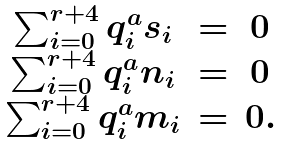<formula> <loc_0><loc_0><loc_500><loc_500>\begin{array} { c c c } \sum _ { i = 0 } ^ { r + 4 } q _ { i } ^ { a } s _ { i } & = & 0 \\ \sum _ { i = 0 } ^ { r + 4 } q _ { i } ^ { a } n _ { i } & = & 0 \\ \sum _ { i = 0 } ^ { r + 4 } q _ { i } ^ { a } m _ { i } & = & 0 . \end{array}</formula> 